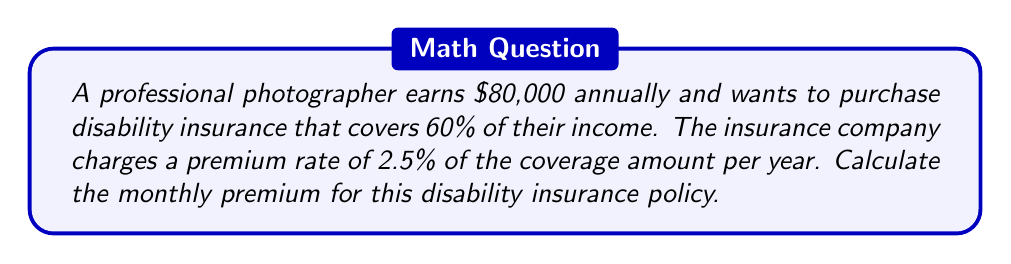Show me your answer to this math problem. Let's break this problem down into steps:

1. Calculate the annual coverage amount:
   Annual income: $80,000
   Coverage percentage: 60%
   $$\text{Annual coverage} = $80,000 \times 60\% = $80,000 \times 0.60 = $48,000$$

2. Calculate the annual premium:
   Premium rate: 2.5% of the coverage amount
   $$\text{Annual premium} = $48,000 \times 2.5\% = $48,000 \times 0.025 = $1,200$$

3. Calculate the monthly premium:
   $$\text{Monthly premium} = \frac{\text{Annual premium}}{12 \text{ months}}$$
   $$\text{Monthly premium} = \frac{$1,200}{12} = $100$$

Therefore, the monthly premium for the photographer's disability insurance policy is $100.
Answer: $100 per month 